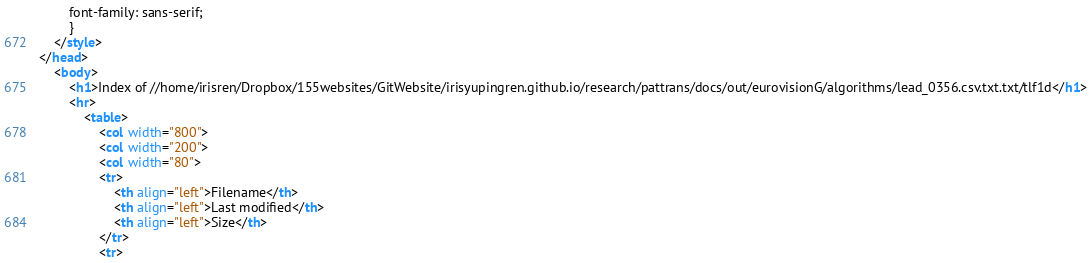<code> <loc_0><loc_0><loc_500><loc_500><_HTML_>        font-family: sans-serif;
        }
    </style>
</head>
    <body>
        <h1>Index of //home/irisren/Dropbox/155websites/GitWebsite/irisyupingren.github.io/research/pattrans/docs/out/eurovisionG/algorithms/lead_0356.csv.txt.txt/tlf1d</h1>
        <hr>
            <table>
                <col width="800">
                <col width="200">
                <col width="80">
                <tr>
                    <th align="left">Filename</th>
                    <th align="left">Last modified</th>
                    <th align="left">Size</th>
                </tr>
                <tr></code> 